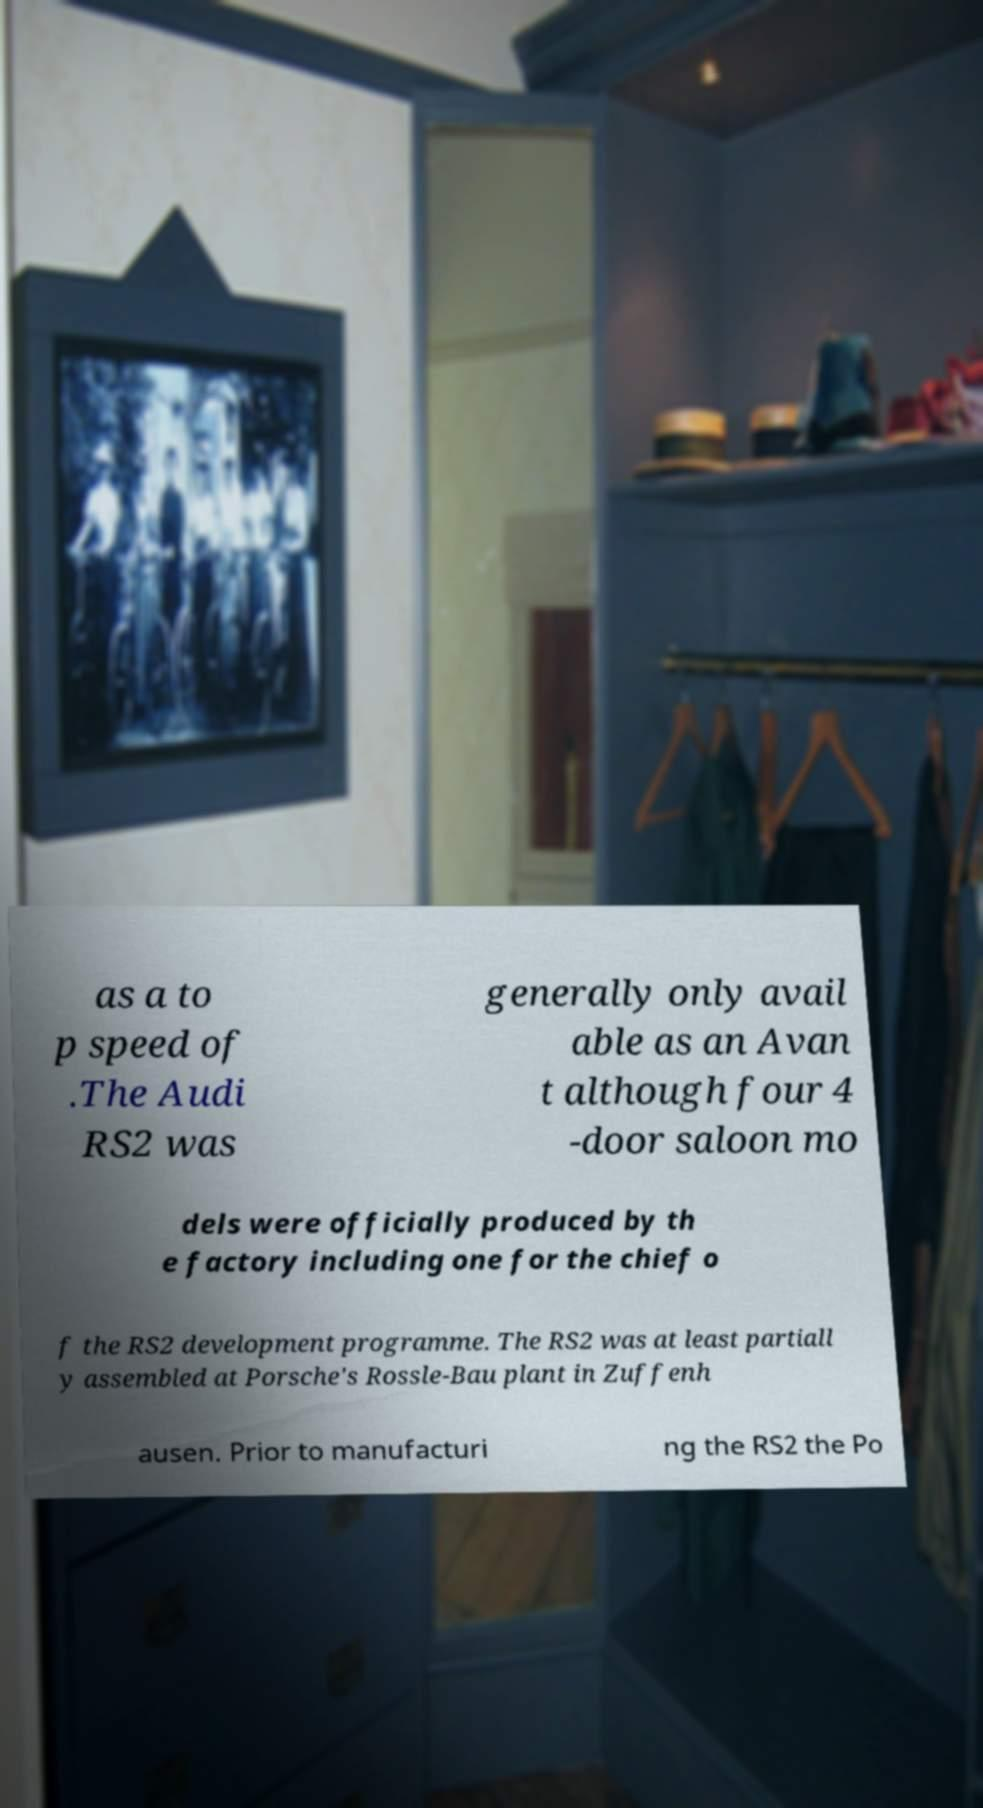Could you extract and type out the text from this image? as a to p speed of .The Audi RS2 was generally only avail able as an Avan t although four 4 -door saloon mo dels were officially produced by th e factory including one for the chief o f the RS2 development programme. The RS2 was at least partiall y assembled at Porsche's Rossle-Bau plant in Zuffenh ausen. Prior to manufacturi ng the RS2 the Po 